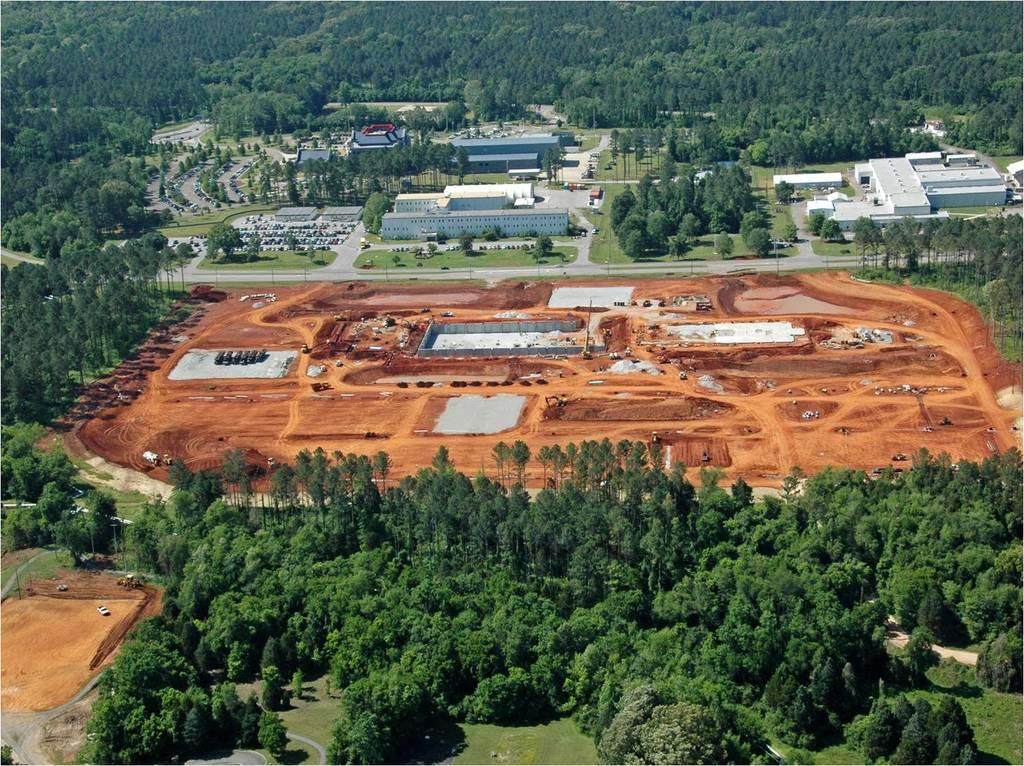What type of view is provided in the image? The image is an aerial view. What type of vegetation can be seen in the image? There are trees and grass visible in the image. What type of man-made structures can be seen in the image? There are buildings visible in the image. What type of transportation infrastructure can be seen in the image? There are roads and vehicles visible in the image. What type of pipe is visible in the image? There is no pipe visible in the image. What type of current is flowing through the buildings in the image? There is no information about currents flowing through the buildings in the image. 